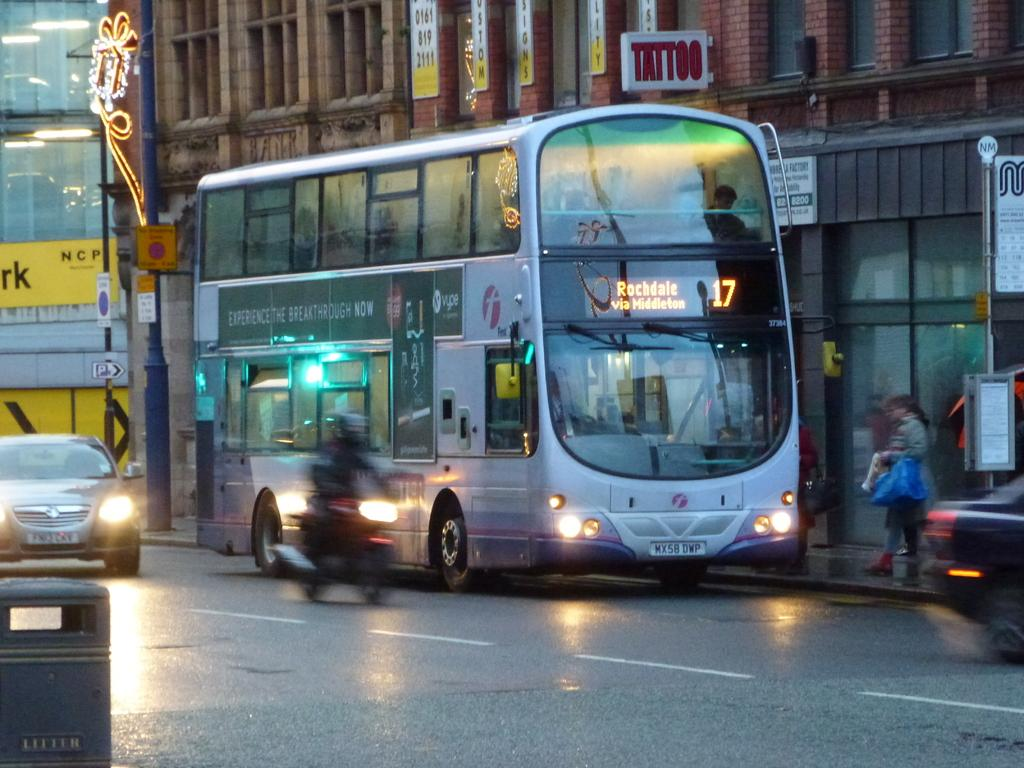What object is located on the road in the foreground of the image? There is a trash bin on the road in the foreground of the image. What can be seen in the background of the image? There are vehicles, people, buildings, and posters in the background of the image. How many chairs can be seen inside the cave in the image? There is no cave or chairs present in the image. What type of ray is swimming near the buildings in the image? There is no ray present in the image; it is a scene on land with a trash bin, vehicles, people, buildings, and posters. 